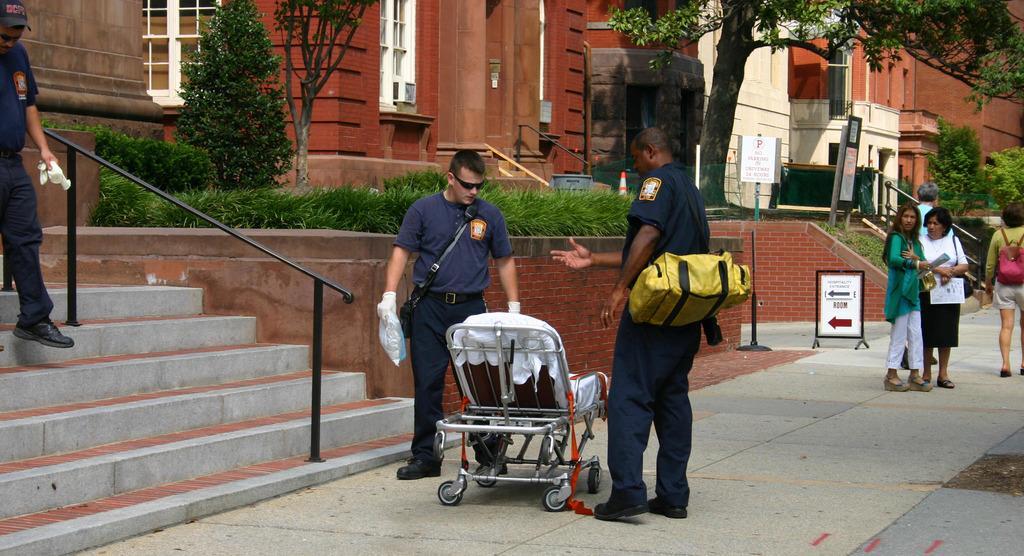Could you give a brief overview of what you see in this image? In this image we can see the buildings. And we can see a few people in front of the building. And we can see the two people beside the baby trolley. And we can see the handrail. And we can see the grass, trees, plants. And we can see the sign boards. 